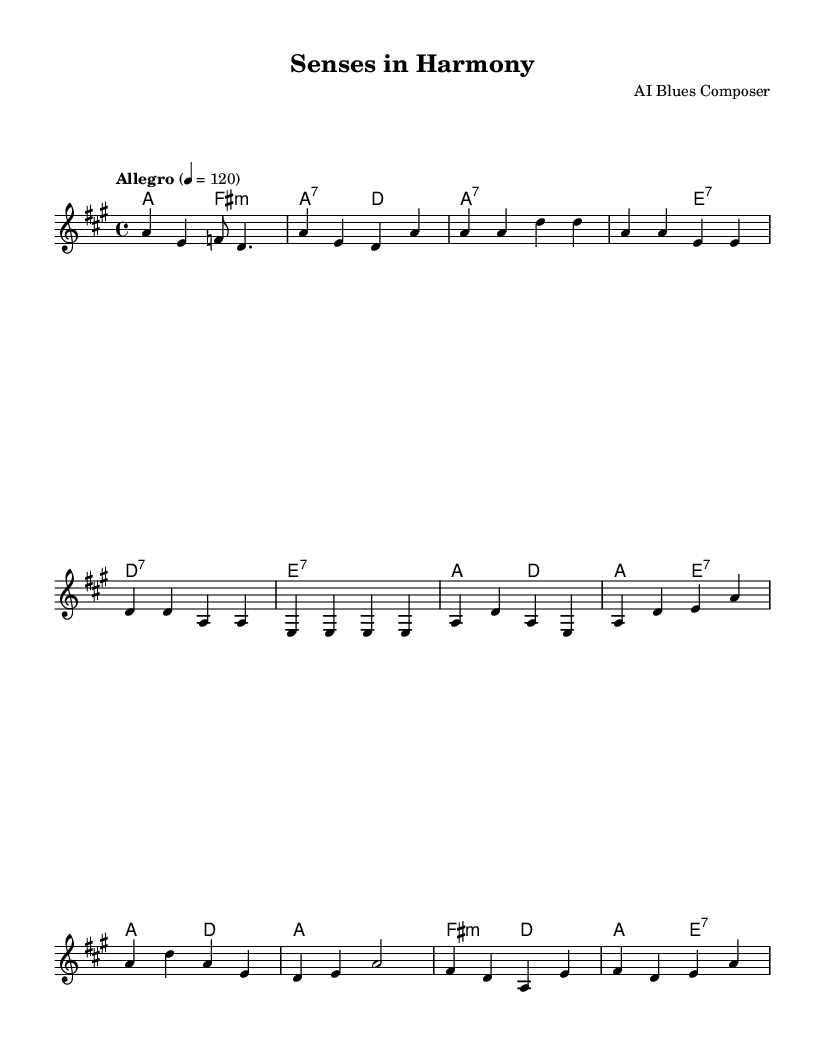What is the key signature of this music? The key signature is A major, which has three sharps: F#, C#, and G#. This can be identified by looking at the beginning of the staff where the sharps are notated.
Answer: A major What is the time signature of this piece? The time signature is 4/4, meaning there are four beats in each measure. This can be found at the beginning of the score, right after the key signature.
Answer: 4/4 What is the tempo marking for this music? The tempo marking is "Allegro", indicating a fast and lively tempo. This is written above the staff and specifies the character of the performance.
Answer: Allegro How many measures are in the verse section? The verse section contains four measures. By counting the measures in the melody part indicated after the introductory section, it becomes clear that there are four distinct phrases.
Answer: Four What is the last chord in the bridge section? The last chord in the bridge section is E7, which can be identified from the chord symbols written above the staff at the end of the bridge.
Answer: E7 Does the melody always start on the same note in the verse? Yes, the melody in the verse always starts on A. By examining the first note of each measure in the verse, it confirms that A is consistently used as the starting note.
Answer: Yes What type of blues is represented in this piece? This piece represents upbeat blues, characterized by its lively tempo and celebratory nature, as indicated by both the tempo marking and the overall harmony and rhythm of the piece.
Answer: Upbeat blues 